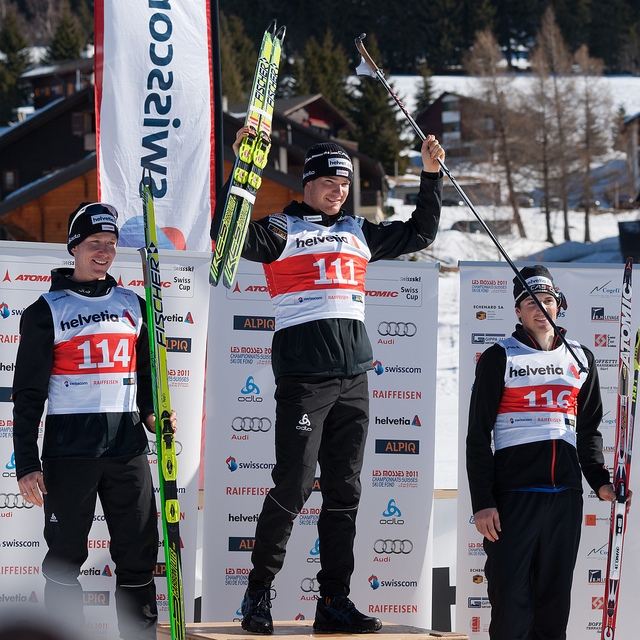How many zebras are there? There are no zebras in the image. The photograph shows three individuals at a podium for a sporting event, with the central person, presumably the winner, raising one arm in victory. 